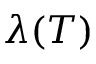Convert formula to latex. <formula><loc_0><loc_0><loc_500><loc_500>\lambda ( T )</formula> 